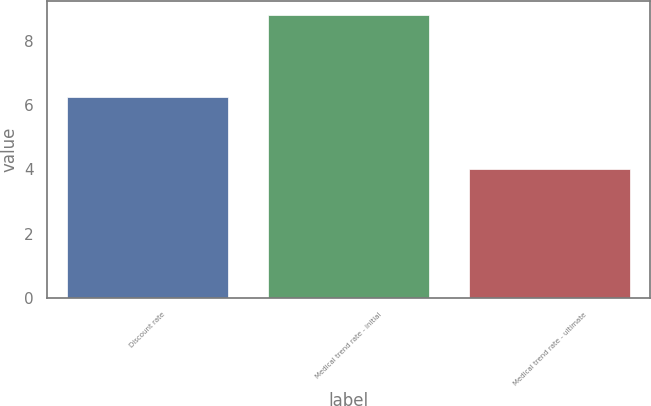Convert chart. <chart><loc_0><loc_0><loc_500><loc_500><bar_chart><fcel>Discount rate<fcel>Medical trend rate - initial<fcel>Medical trend rate - ultimate<nl><fcel>6.25<fcel>8.8<fcel>4<nl></chart> 